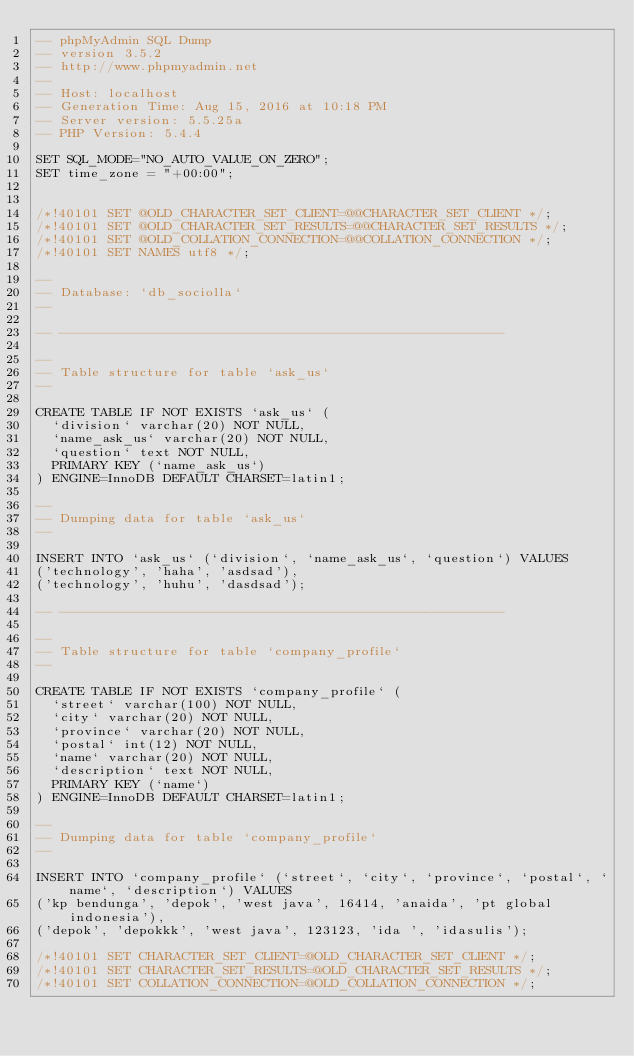Convert code to text. <code><loc_0><loc_0><loc_500><loc_500><_SQL_>-- phpMyAdmin SQL Dump
-- version 3.5.2
-- http://www.phpmyadmin.net
--
-- Host: localhost
-- Generation Time: Aug 15, 2016 at 10:18 PM
-- Server version: 5.5.25a
-- PHP Version: 5.4.4

SET SQL_MODE="NO_AUTO_VALUE_ON_ZERO";
SET time_zone = "+00:00";


/*!40101 SET @OLD_CHARACTER_SET_CLIENT=@@CHARACTER_SET_CLIENT */;
/*!40101 SET @OLD_CHARACTER_SET_RESULTS=@@CHARACTER_SET_RESULTS */;
/*!40101 SET @OLD_COLLATION_CONNECTION=@@COLLATION_CONNECTION */;
/*!40101 SET NAMES utf8 */;

--
-- Database: `db_sociolla`
--

-- --------------------------------------------------------

--
-- Table structure for table `ask_us`
--

CREATE TABLE IF NOT EXISTS `ask_us` (
  `division` varchar(20) NOT NULL,
  `name_ask_us` varchar(20) NOT NULL,
  `question` text NOT NULL,
  PRIMARY KEY (`name_ask_us`)
) ENGINE=InnoDB DEFAULT CHARSET=latin1;

--
-- Dumping data for table `ask_us`
--

INSERT INTO `ask_us` (`division`, `name_ask_us`, `question`) VALUES
('technology', 'haha', 'asdsad'),
('technology', 'huhu', 'dasdsad');

-- --------------------------------------------------------

--
-- Table structure for table `company_profile`
--

CREATE TABLE IF NOT EXISTS `company_profile` (
  `street` varchar(100) NOT NULL,
  `city` varchar(20) NOT NULL,
  `province` varchar(20) NOT NULL,
  `postal` int(12) NOT NULL,
  `name` varchar(20) NOT NULL,
  `description` text NOT NULL,
  PRIMARY KEY (`name`)
) ENGINE=InnoDB DEFAULT CHARSET=latin1;

--
-- Dumping data for table `company_profile`
--

INSERT INTO `company_profile` (`street`, `city`, `province`, `postal`, `name`, `description`) VALUES
('kp bendunga', 'depok', 'west java', 16414, 'anaida', 'pt global indonesia'),
('depok', 'depokkk', 'west java', 123123, 'ida ', 'idasulis');

/*!40101 SET CHARACTER_SET_CLIENT=@OLD_CHARACTER_SET_CLIENT */;
/*!40101 SET CHARACTER_SET_RESULTS=@OLD_CHARACTER_SET_RESULTS */;
/*!40101 SET COLLATION_CONNECTION=@OLD_COLLATION_CONNECTION */;
</code> 